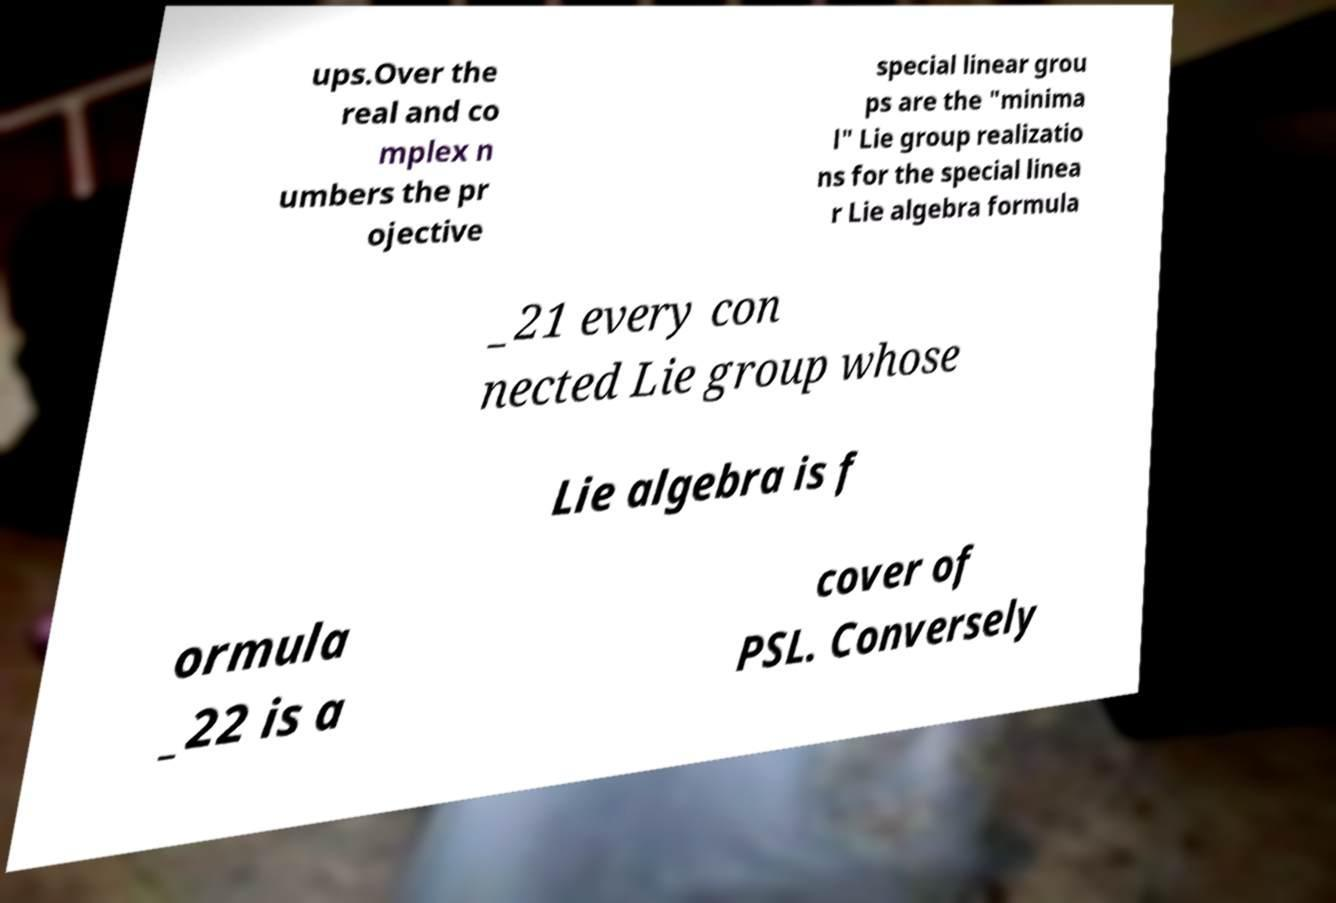There's text embedded in this image that I need extracted. Can you transcribe it verbatim? ups.Over the real and co mplex n umbers the pr ojective special linear grou ps are the "minima l" Lie group realizatio ns for the special linea r Lie algebra formula _21 every con nected Lie group whose Lie algebra is f ormula _22 is a cover of PSL. Conversely 